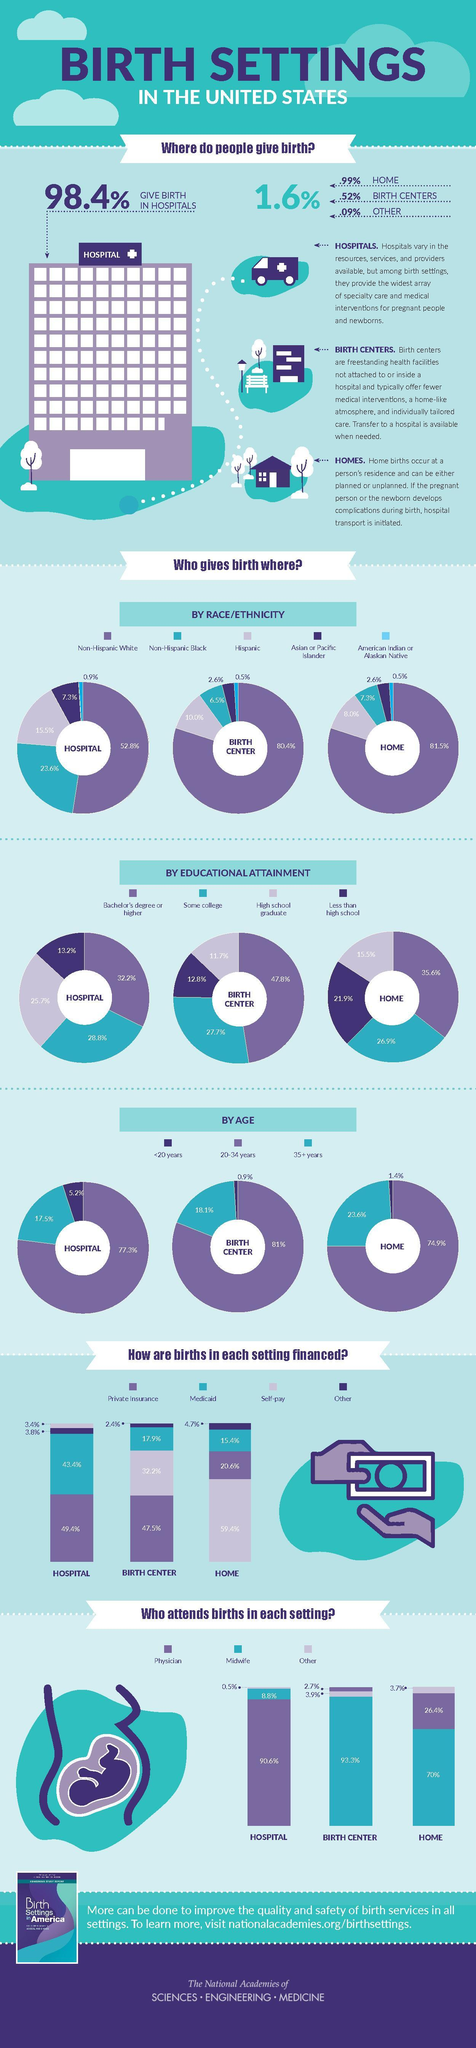Based on the ethinicity, what is the difference in percentage value of American Indians giving birth at home and at the birth center ?
Answer the question with a short phrase. 0 What is the total percentage of American Indian and Asians giving birth at the birth center ? 3.1% What is the percentage aggregate of Non-Hispanic White and Black who give birth in hospitals ? 76.4% How many places do people give birth? 4 What is the lowest percentage value of births attended by midwives is for Home, Hospitals, or Birth Center? Hospitals What is percentage increase in women aged 20-34 years giving birth at the birth center in comparison to the women who give birth at home? 6.1% What is the total percentage of Hispanics and Asians giving birth at home ? 10.9% What is the difference in percentage of women who give birth in a birth center or a hospital if they have Bachelor's degree ? 15.6% Calculate the total percentage of births financed through Medicaid at Hospitals, Birth centers and Home? 76.7% What is the highest percentage value of  births attended by others is for Birth Centers, Hospitals, or Homes? Homes 